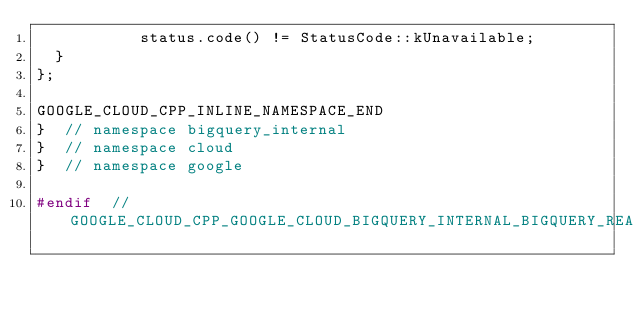<code> <loc_0><loc_0><loc_500><loc_500><_C_>           status.code() != StatusCode::kUnavailable;
  }
};

GOOGLE_CLOUD_CPP_INLINE_NAMESPACE_END
}  // namespace bigquery_internal
}  // namespace cloud
}  // namespace google

#endif  // GOOGLE_CLOUD_CPP_GOOGLE_CLOUD_BIGQUERY_INTERNAL_BIGQUERY_READ_RETRY_TRAITS_H
</code> 